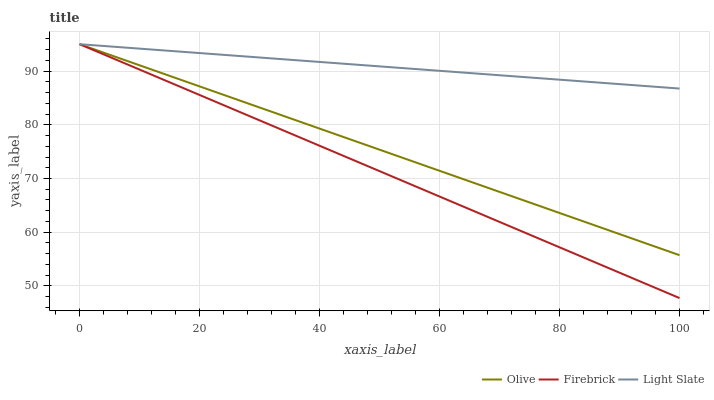Does Firebrick have the minimum area under the curve?
Answer yes or no. Yes. Does Light Slate have the maximum area under the curve?
Answer yes or no. Yes. Does Light Slate have the minimum area under the curve?
Answer yes or no. No. Does Firebrick have the maximum area under the curve?
Answer yes or no. No. Is Olive the smoothest?
Answer yes or no. Yes. Is Light Slate the roughest?
Answer yes or no. Yes. Is Firebrick the smoothest?
Answer yes or no. No. Is Firebrick the roughest?
Answer yes or no. No. Does Firebrick have the lowest value?
Answer yes or no. Yes. Does Light Slate have the lowest value?
Answer yes or no. No. Does Firebrick have the highest value?
Answer yes or no. Yes. Does Firebrick intersect Light Slate?
Answer yes or no. Yes. Is Firebrick less than Light Slate?
Answer yes or no. No. Is Firebrick greater than Light Slate?
Answer yes or no. No. 